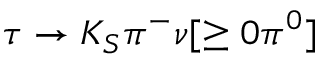Convert formula to latex. <formula><loc_0><loc_0><loc_500><loc_500>\tau \to K _ { S } \pi ^ { - } \nu [ \geq 0 \pi ^ { 0 } ]</formula> 